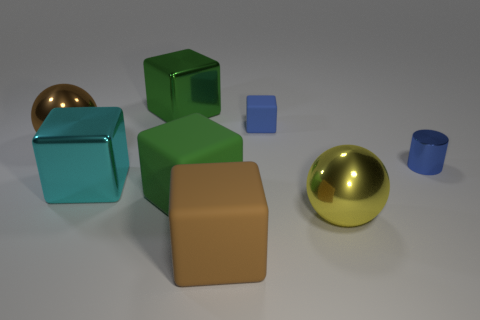Subtract 2 blocks. How many blocks are left? 3 Subtract all large brown cubes. How many cubes are left? 4 Subtract all blue blocks. How many blocks are left? 4 Subtract all brown blocks. Subtract all green balls. How many blocks are left? 4 Add 1 small blue things. How many objects exist? 9 Subtract all cylinders. How many objects are left? 7 Subtract 0 green cylinders. How many objects are left? 8 Subtract all small brown cubes. Subtract all cylinders. How many objects are left? 7 Add 3 large cyan shiny objects. How many large cyan shiny objects are left? 4 Add 8 brown matte things. How many brown matte things exist? 9 